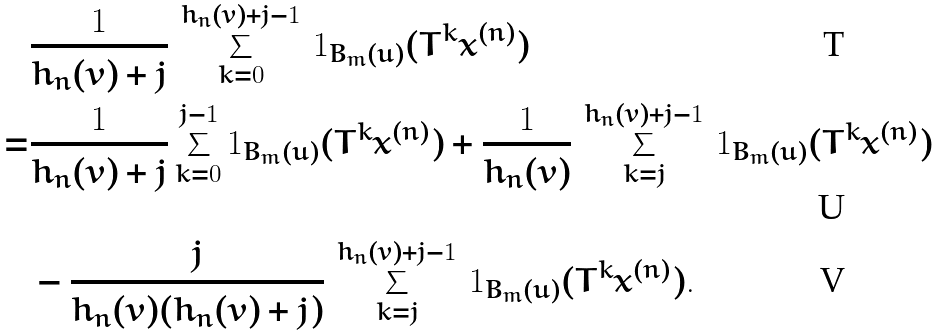<formula> <loc_0><loc_0><loc_500><loc_500>& \frac { 1 } { h _ { n } ( v ) + j } \, \sum _ { k = 0 } ^ { h _ { n } ( v ) + j - 1 } \, { 1 } _ { B _ { m } ( u ) } ( T ^ { k } x ^ { ( n ) } ) \\ = & \frac { 1 } { h _ { n } ( v ) + j } \sum _ { k = 0 } ^ { j - 1 } { 1 } _ { B _ { m } ( u ) } ( T ^ { k } x ^ { ( n ) } ) + \frac { 1 } { h _ { n } ( v ) } \, \sum _ { k = j } ^ { h _ { n } ( v ) + j - 1 } \, { 1 } _ { B _ { m } ( u ) } ( T ^ { k } x ^ { ( n ) } ) \\ & - \frac { j } { h _ { n } ( v ) ( h _ { n } ( v ) + j ) } \, \sum _ { k = j } ^ { h _ { n } ( v ) + j - 1 } \, { 1 } _ { B _ { m } ( u ) } ( T ^ { k } x ^ { ( n ) } ) .</formula> 